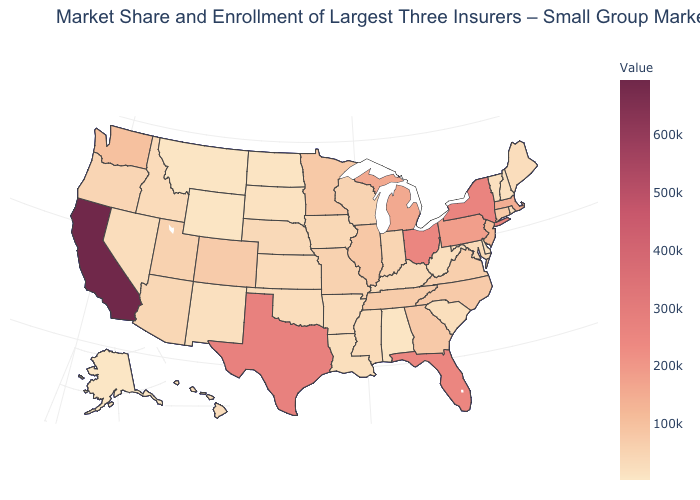Does the map have missing data?
Quick response, please. No. Does the map have missing data?
Be succinct. No. Among the states that border Mississippi , which have the lowest value?
Give a very brief answer. Alabama. Does the map have missing data?
Keep it brief. No. Among the states that border Georgia , which have the highest value?
Concise answer only. Florida. Which states hav the highest value in the MidWest?
Quick response, please. Ohio. Among the states that border California , which have the highest value?
Be succinct. Oregon. 